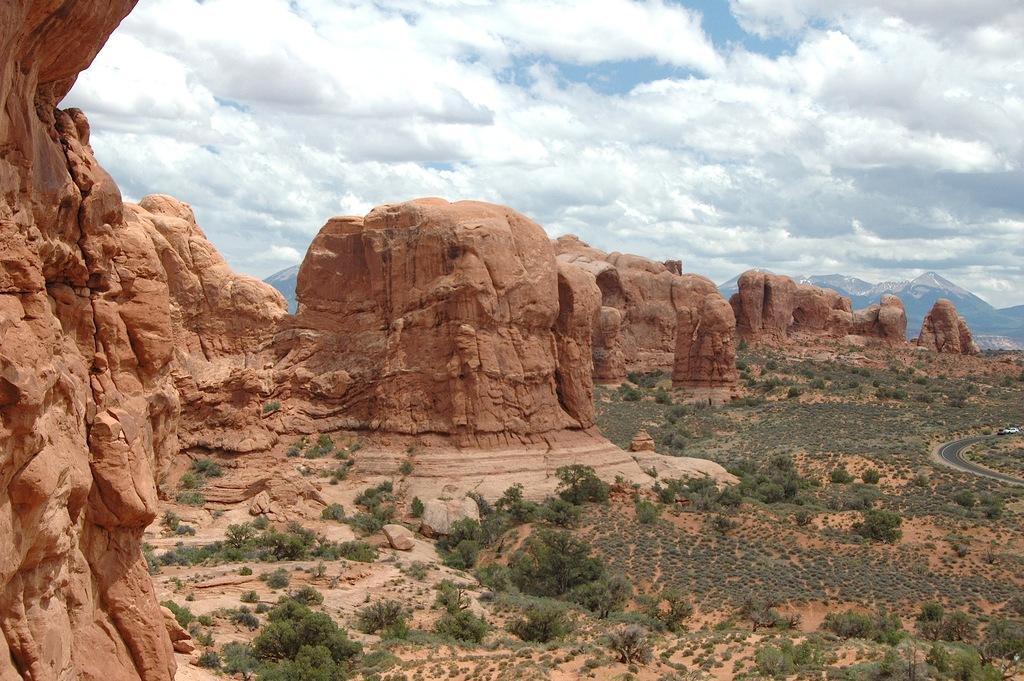What is the main feature in the center of the image? There are mountains in the center of the image. What type of vegetation can be seen on the ground? There is grass on the ground. Are there any other plants visible in the image? Yes, there are plants in the image. How would you describe the sky in the image? The sky is cloudy. What can be seen in the front of the image? There are rocks in the front of the image. Can you see any beetles crawling on the rocks in the image? There are no beetles visible in the image; it only shows mountains, grass, plants, a cloudy sky, and rocks. 